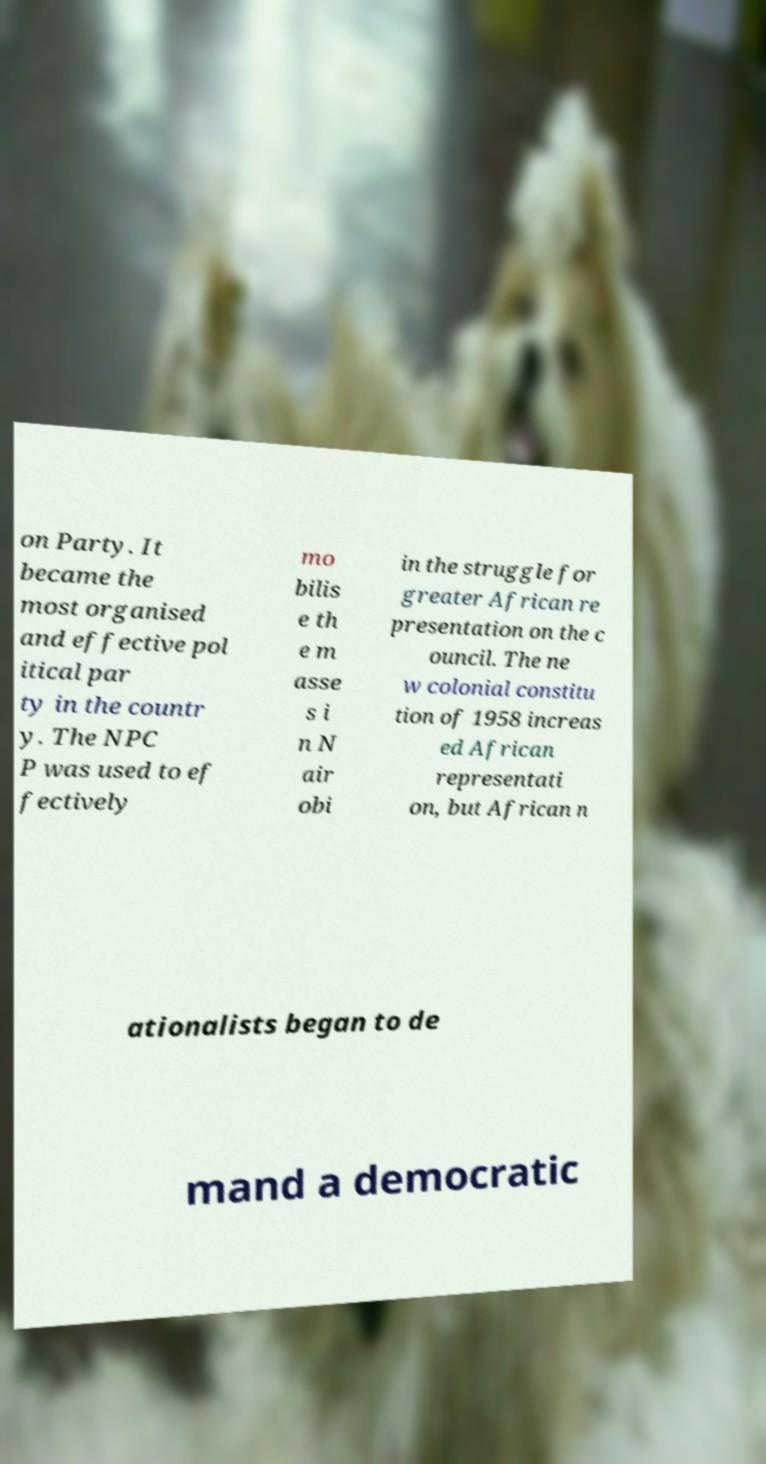Please identify and transcribe the text found in this image. on Party. It became the most organised and effective pol itical par ty in the countr y. The NPC P was used to ef fectively mo bilis e th e m asse s i n N air obi in the struggle for greater African re presentation on the c ouncil. The ne w colonial constitu tion of 1958 increas ed African representati on, but African n ationalists began to de mand a democratic 